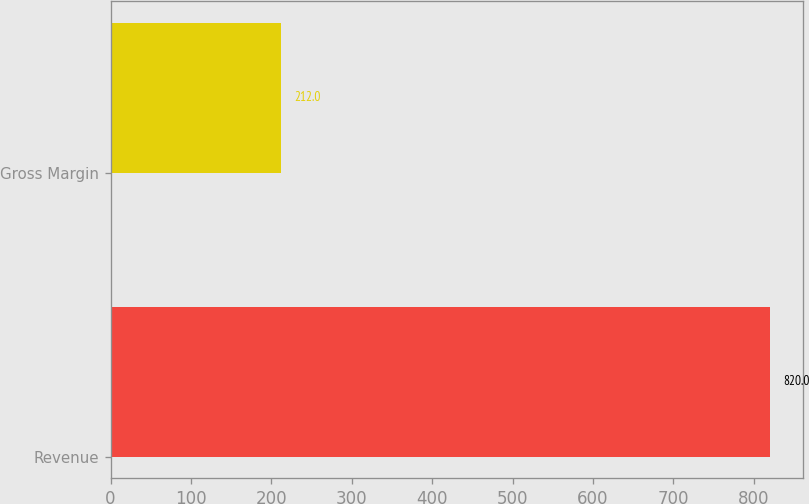Convert chart to OTSL. <chart><loc_0><loc_0><loc_500><loc_500><bar_chart><fcel>Revenue<fcel>Gross Margin<nl><fcel>820<fcel>212<nl></chart> 